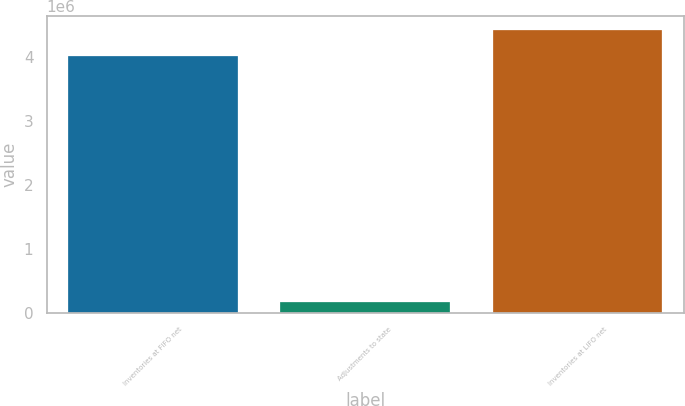<chart> <loc_0><loc_0><loc_500><loc_500><bar_chart><fcel>Inventories at FIFO net<fcel>Adjustments to state<fcel>Inventories at LIFO net<nl><fcel>4.00964e+06<fcel>165127<fcel>4.41061e+06<nl></chart> 